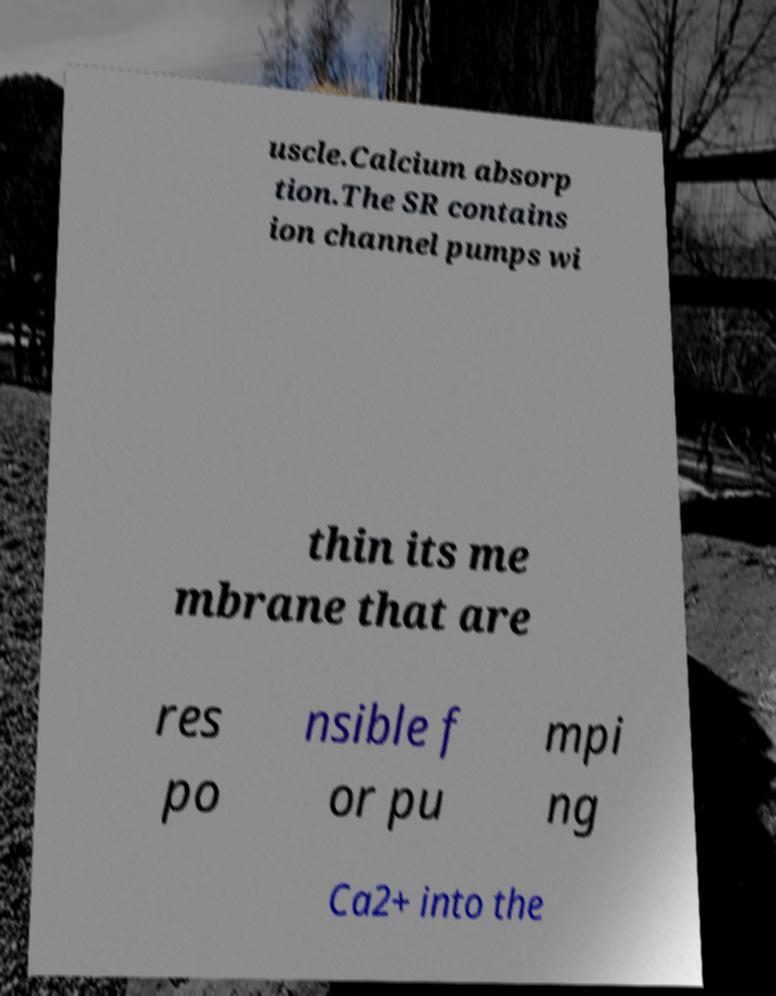Can you accurately transcribe the text from the provided image for me? uscle.Calcium absorp tion.The SR contains ion channel pumps wi thin its me mbrane that are res po nsible f or pu mpi ng Ca2+ into the 